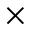<formula> <loc_0><loc_0><loc_500><loc_500>\times</formula> 